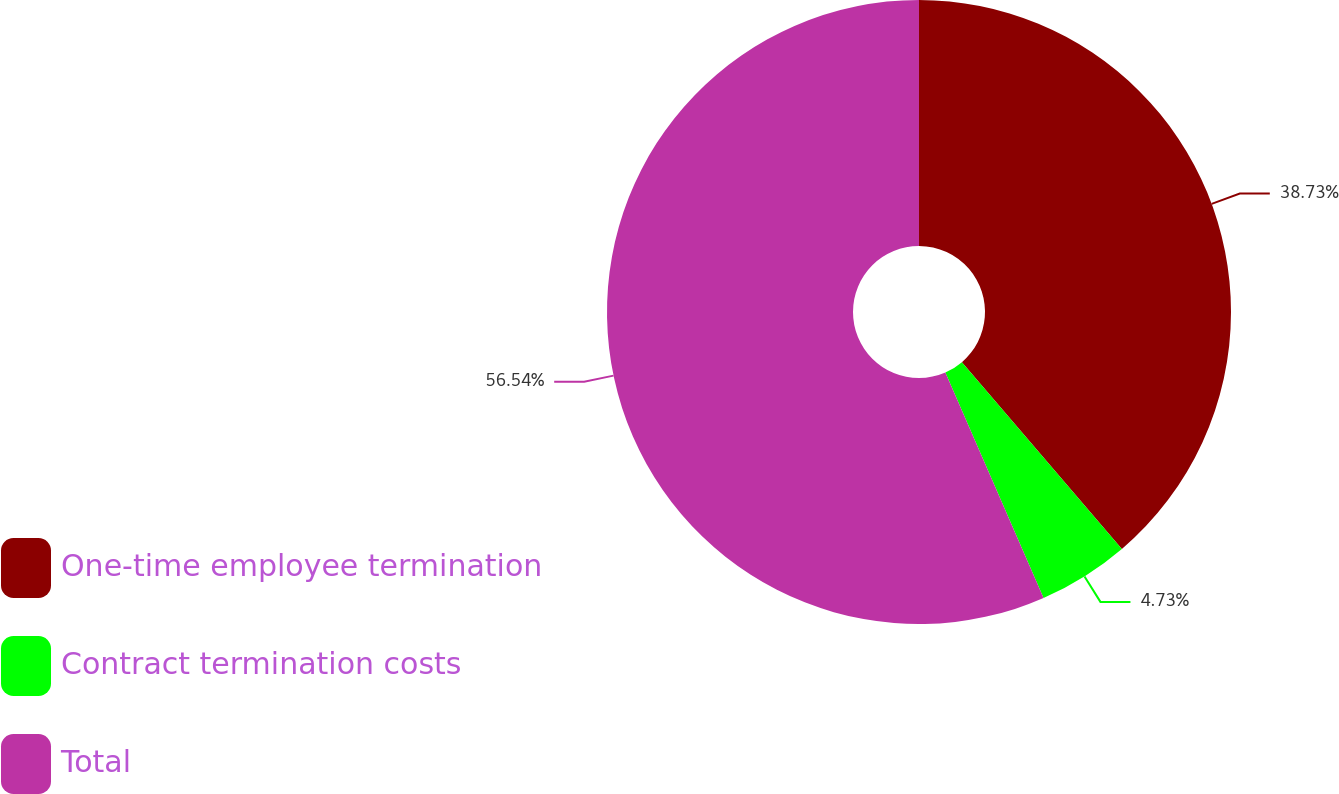Convert chart to OTSL. <chart><loc_0><loc_0><loc_500><loc_500><pie_chart><fcel>One-time employee termination<fcel>Contract termination costs<fcel>Total<nl><fcel>38.73%<fcel>4.73%<fcel>56.53%<nl></chart> 